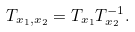Convert formula to latex. <formula><loc_0><loc_0><loc_500><loc_500>T _ { x _ { 1 } , x _ { 2 } } = T _ { x _ { 1 } } T _ { x _ { 2 } } ^ { - 1 } . \\</formula> 